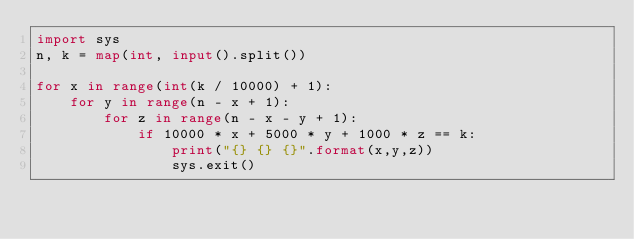<code> <loc_0><loc_0><loc_500><loc_500><_Python_>import sys
n, k = map(int, input().split())

for x in range(int(k / 10000) + 1):
    for y in range(n - x + 1):
        for z in range(n - x - y + 1):
            if 10000 * x + 5000 * y + 1000 * z == k:
                print("{} {} {}".format(x,y,z))
                sys.exit()
</code> 